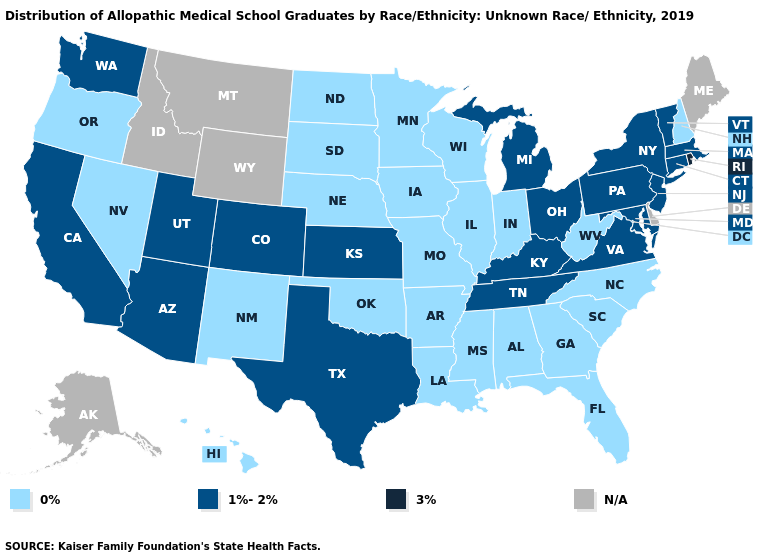Does the first symbol in the legend represent the smallest category?
Quick response, please. Yes. Which states have the lowest value in the USA?
Concise answer only. Alabama, Arkansas, Florida, Georgia, Hawaii, Illinois, Indiana, Iowa, Louisiana, Minnesota, Mississippi, Missouri, Nebraska, Nevada, New Hampshire, New Mexico, North Carolina, North Dakota, Oklahoma, Oregon, South Carolina, South Dakota, West Virginia, Wisconsin. Name the states that have a value in the range N/A?
Keep it brief. Alaska, Delaware, Idaho, Maine, Montana, Wyoming. What is the lowest value in the West?
Answer briefly. 0%. What is the value of Iowa?
Be succinct. 0%. What is the lowest value in states that border Louisiana?
Short answer required. 0%. Among the states that border Oklahoma , which have the lowest value?
Write a very short answer. Arkansas, Missouri, New Mexico. Does Missouri have the highest value in the USA?
Be succinct. No. Name the states that have a value in the range N/A?
Be succinct. Alaska, Delaware, Idaho, Maine, Montana, Wyoming. How many symbols are there in the legend?
Keep it brief. 4. Name the states that have a value in the range 1%-2%?
Concise answer only. Arizona, California, Colorado, Connecticut, Kansas, Kentucky, Maryland, Massachusetts, Michigan, New Jersey, New York, Ohio, Pennsylvania, Tennessee, Texas, Utah, Vermont, Virginia, Washington. Is the legend a continuous bar?
Concise answer only. No. Which states hav the highest value in the Northeast?
Quick response, please. Rhode Island. 